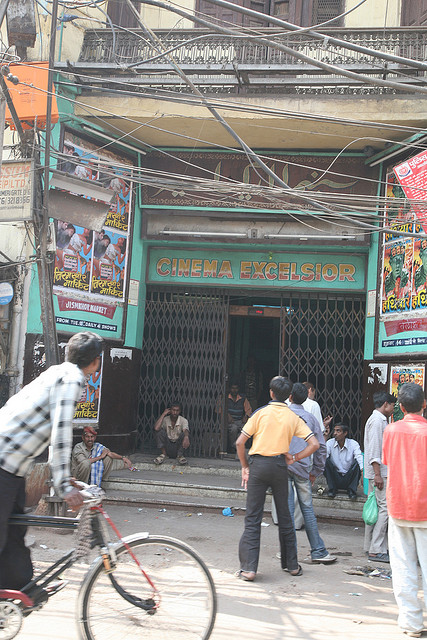If the cinema could tell its story, what would it say about its history? If 'CINEMA EXCELSIOR' could narrate its tale, it would likely recount decades of serving the local community as a beloved hub of entertainment. It might describe the countless movie nights, the audience’s laughter and gasps, and how it has witnessed the evolution of films from black-and-white classics to the modern-day blockbusters. The cinema would have tales of first dates, family outings, and solo visits, becoming a backdrop for many personal memories. It might speak of its resilience, standing tall despite the changes in the neighborhood, representing continuity and nostalgia for many who consider it a cherished landmark. Imagine an eventful night at the cinema decades ago. What might have occurred? On an eventful night decades ago, 'CINEMA EXCELSIOR' might have been packed with excited moviegoers eagerly awaiting the premiere of a new local blockbuster. The air could have been filled with chatter and the smell of freshly popped popcorn. Families, friends, and movie enthusiasts from nearby neighborhoods could gather, leading to a sold-out show. Amidst the hustle and bustle, street vendors might set up outside, selling snacks and souvenirs. Inside, the atmosphere would be electric, with the audience reacting passionately to the film’s dramatic peaks and thrilling action sequences. Such a night would solidify the cinema’s reputation as a central spot for entertainment and community gatherings. 